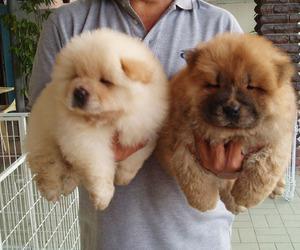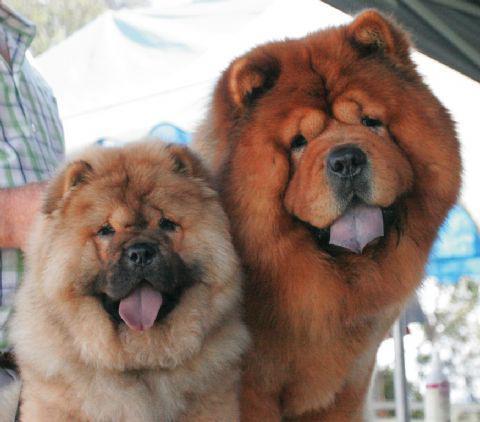The first image is the image on the left, the second image is the image on the right. For the images shown, is this caption "There are no less than two dogs in each image." true? Answer yes or no. Yes. The first image is the image on the left, the second image is the image on the right. Evaluate the accuracy of this statement regarding the images: "There two dogs in total.". Is it true? Answer yes or no. No. The first image is the image on the left, the second image is the image on the right. Given the left and right images, does the statement "There are only two dogs." hold true? Answer yes or no. No. The first image is the image on the left, the second image is the image on the right. Given the left and right images, does the statement "Each image contains exactly one chow dog, and at least one image shows a dog standing in profile on grass." hold true? Answer yes or no. No. 